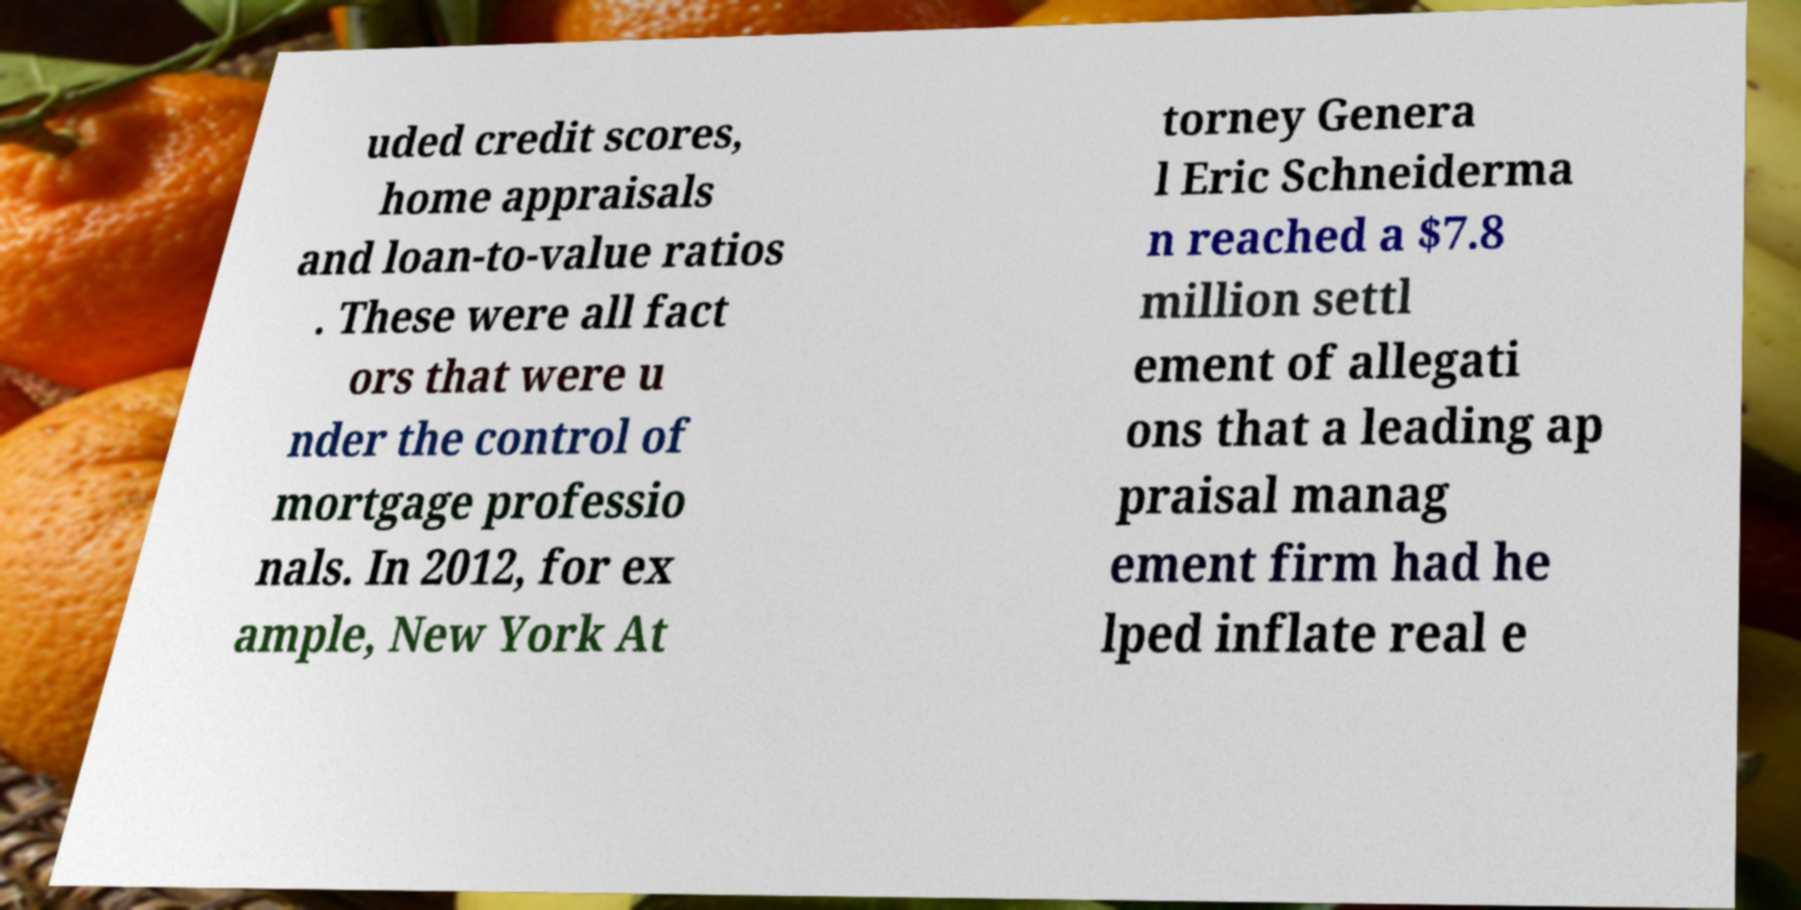For documentation purposes, I need the text within this image transcribed. Could you provide that? uded credit scores, home appraisals and loan-to-value ratios . These were all fact ors that were u nder the control of mortgage professio nals. In 2012, for ex ample, New York At torney Genera l Eric Schneiderma n reached a $7.8 million settl ement of allegati ons that a leading ap praisal manag ement firm had he lped inflate real e 